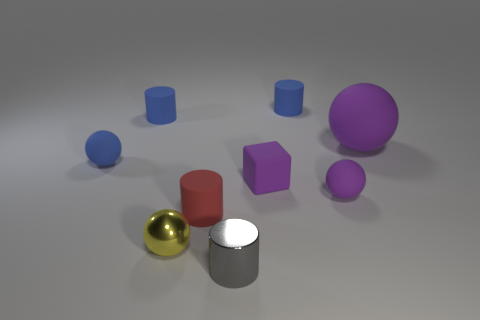Are there the same number of tiny matte cylinders that are in front of the gray cylinder and yellow metallic spheres?
Give a very brief answer. No. There is a large sphere that is the same color as the small rubber block; what is it made of?
Offer a very short reply. Rubber. Do the gray metallic object and the blue matte cylinder left of the purple matte cube have the same size?
Ensure brevity in your answer.  Yes. What number of other objects are the same size as the purple matte block?
Your answer should be compact. 7. What number of other objects are there of the same color as the tiny block?
Give a very brief answer. 2. Are there any other things that are the same size as the yellow sphere?
Your response must be concise. Yes. How many other things are the same shape as the tiny red rubber object?
Ensure brevity in your answer.  3. Is the purple rubber block the same size as the gray cylinder?
Make the answer very short. Yes. Is there a big thing?
Offer a terse response. Yes. Is there anything else that has the same material as the cube?
Your answer should be very brief. Yes. 